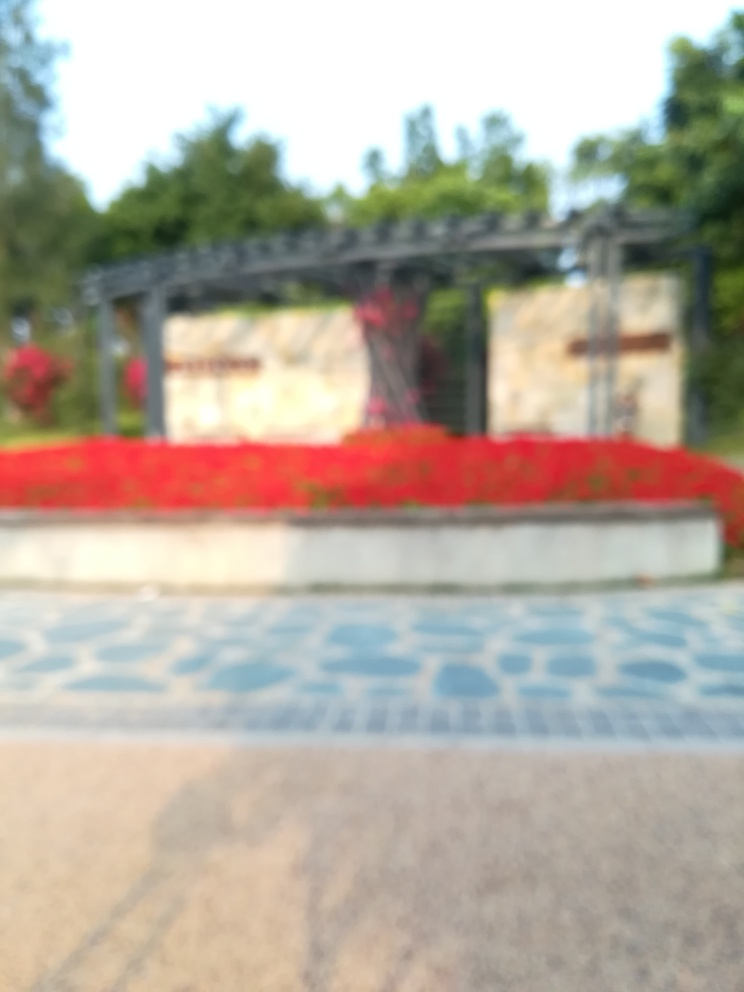Does the image give any indication of the season? The vibrant red, which could be from flowering plants, suggests a season when such botanical elements are in full bloom, potentially spring or summer. Yet, without a clearer image, it's difficult to ascertain seasonal details accurately. 